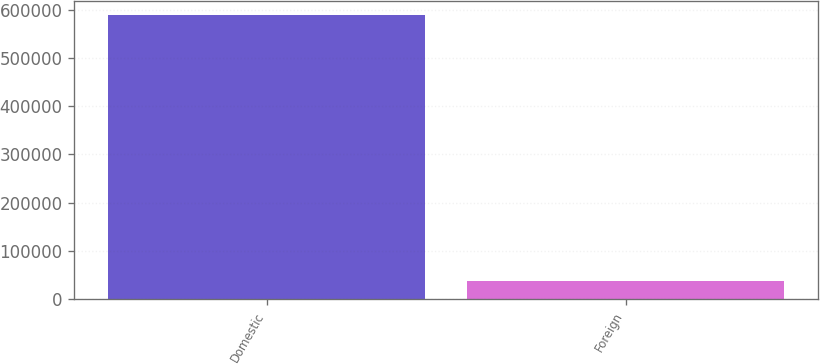<chart> <loc_0><loc_0><loc_500><loc_500><bar_chart><fcel>Domestic<fcel>Foreign<nl><fcel>590024<fcel>37679<nl></chart> 